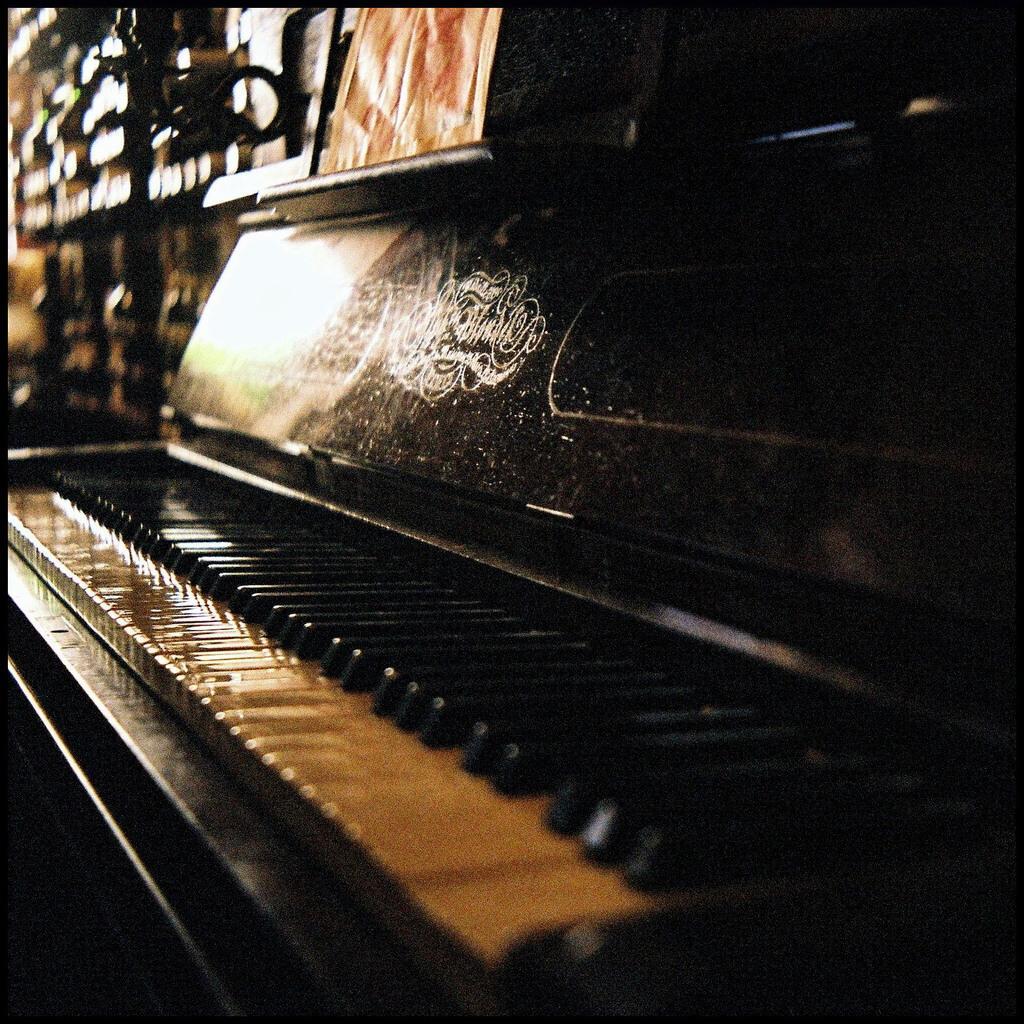Describe this image in one or two sentences. A piano is shown in the picture. There are some patterns on it. The white keys are appearing pale yellow due to darkness. 